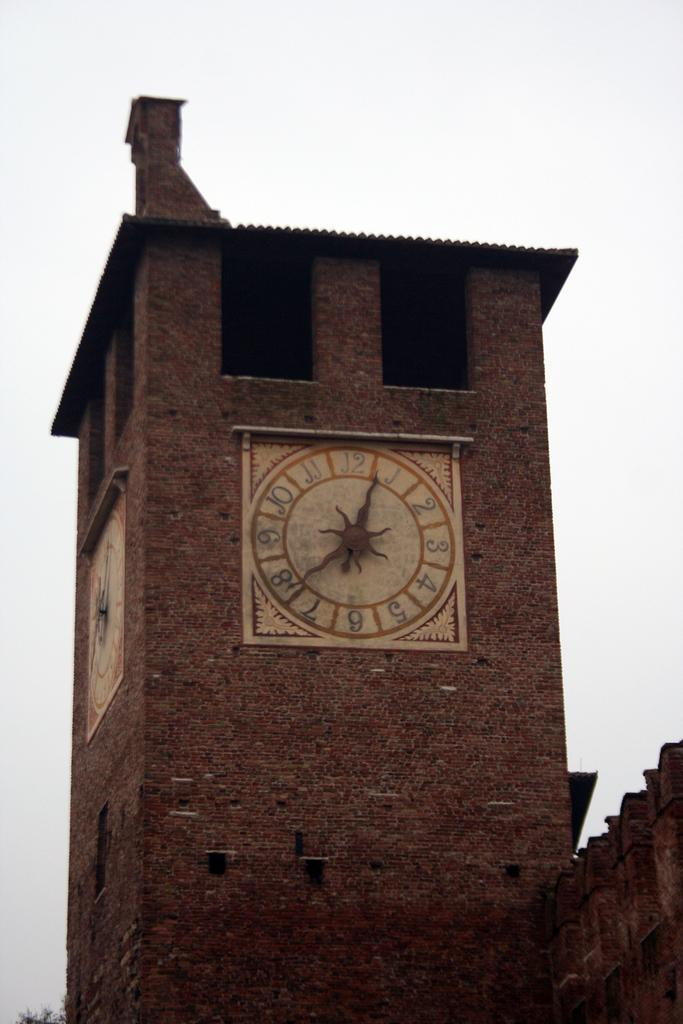<image>
Provide a brief description of the given image. A old brick building with a clock displaying 12:40. 